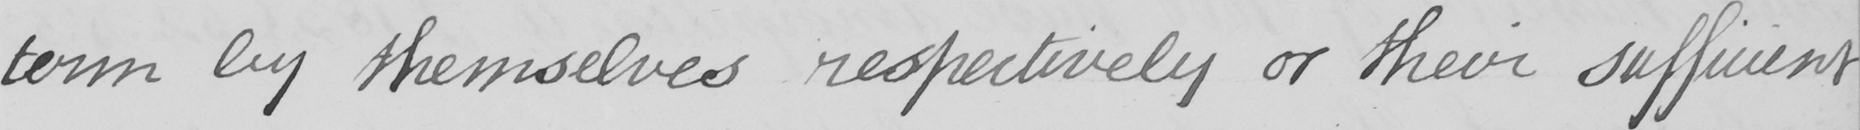What text is written in this handwritten line? term by themselves respectively or their sufficient 